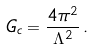Convert formula to latex. <formula><loc_0><loc_0><loc_500><loc_500>G _ { c } = \frac { 4 \pi ^ { 2 } } { \Lambda ^ { 2 } } \, .</formula> 